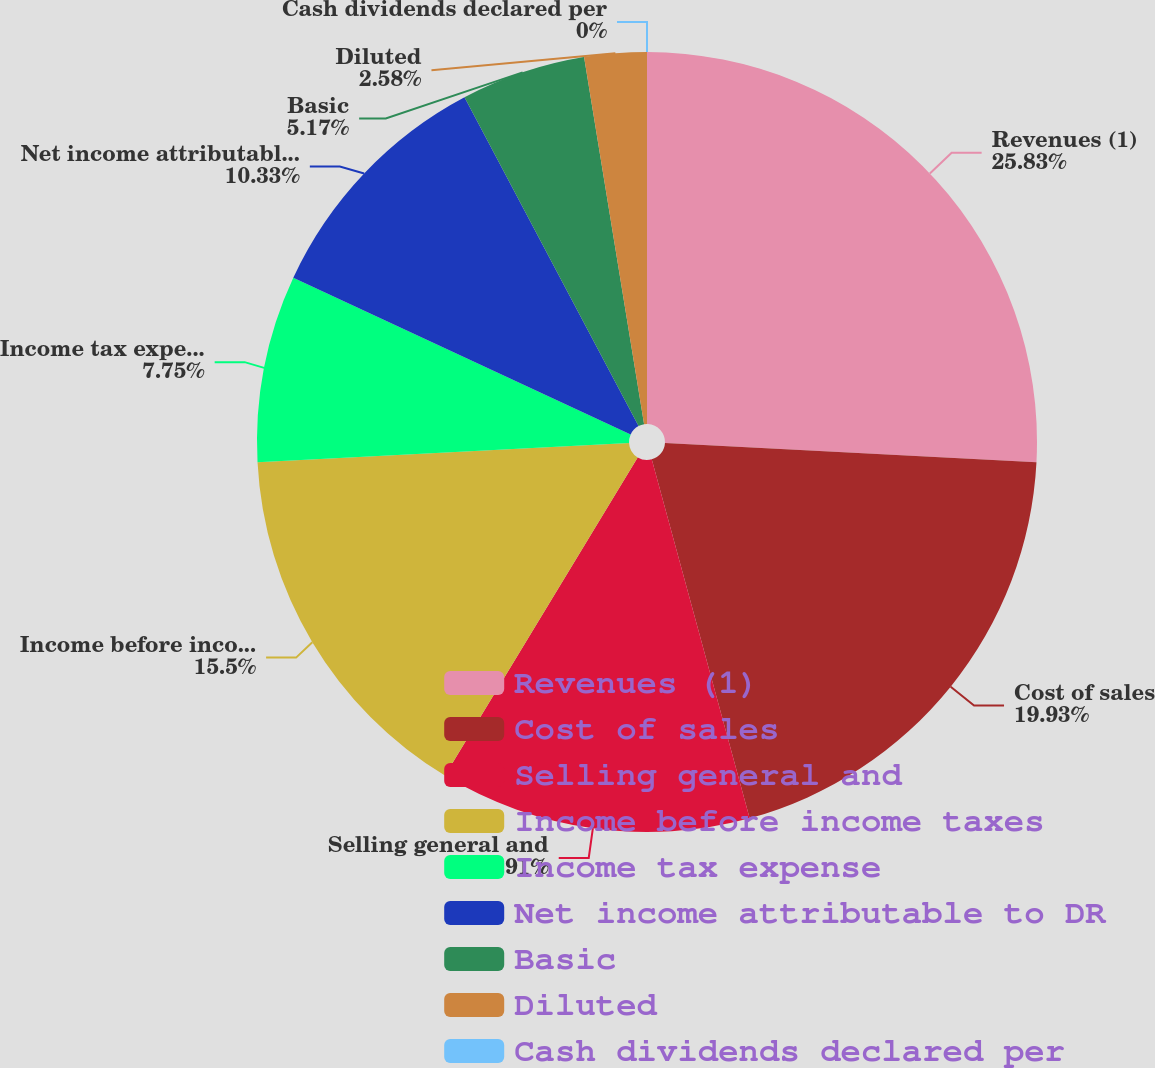Convert chart to OTSL. <chart><loc_0><loc_0><loc_500><loc_500><pie_chart><fcel>Revenues (1)<fcel>Cost of sales<fcel>Selling general and<fcel>Income before income taxes<fcel>Income tax expense<fcel>Net income attributable to DR<fcel>Basic<fcel>Diluted<fcel>Cash dividends declared per<nl><fcel>25.83%<fcel>19.93%<fcel>12.91%<fcel>15.5%<fcel>7.75%<fcel>10.33%<fcel>5.17%<fcel>2.58%<fcel>0.0%<nl></chart> 